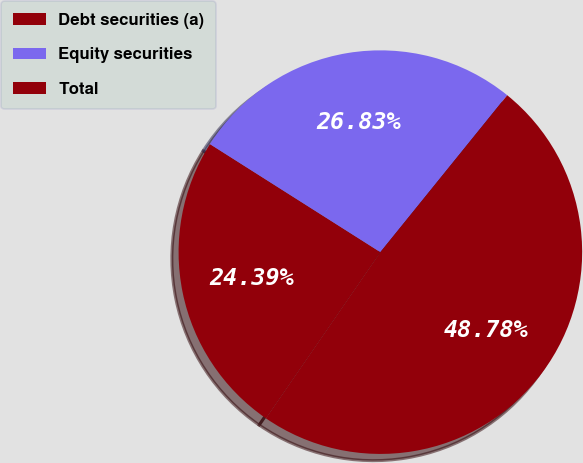Convert chart to OTSL. <chart><loc_0><loc_0><loc_500><loc_500><pie_chart><fcel>Debt securities (a)<fcel>Equity securities<fcel>Total<nl><fcel>24.39%<fcel>26.83%<fcel>48.78%<nl></chart> 